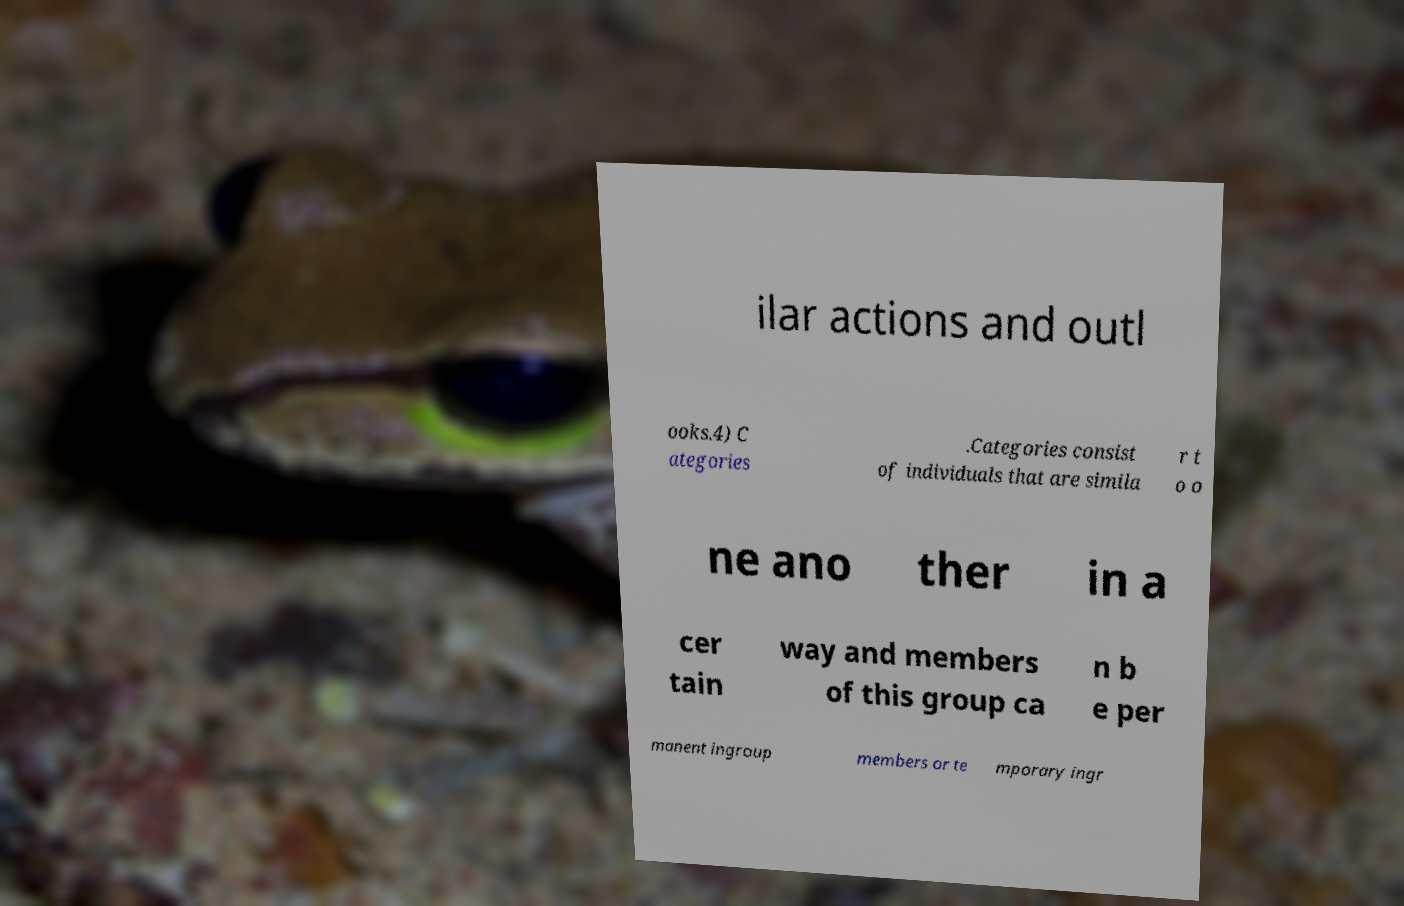What messages or text are displayed in this image? I need them in a readable, typed format. ilar actions and outl ooks.4) C ategories .Categories consist of individuals that are simila r t o o ne ano ther in a cer tain way and members of this group ca n b e per manent ingroup members or te mporary ingr 